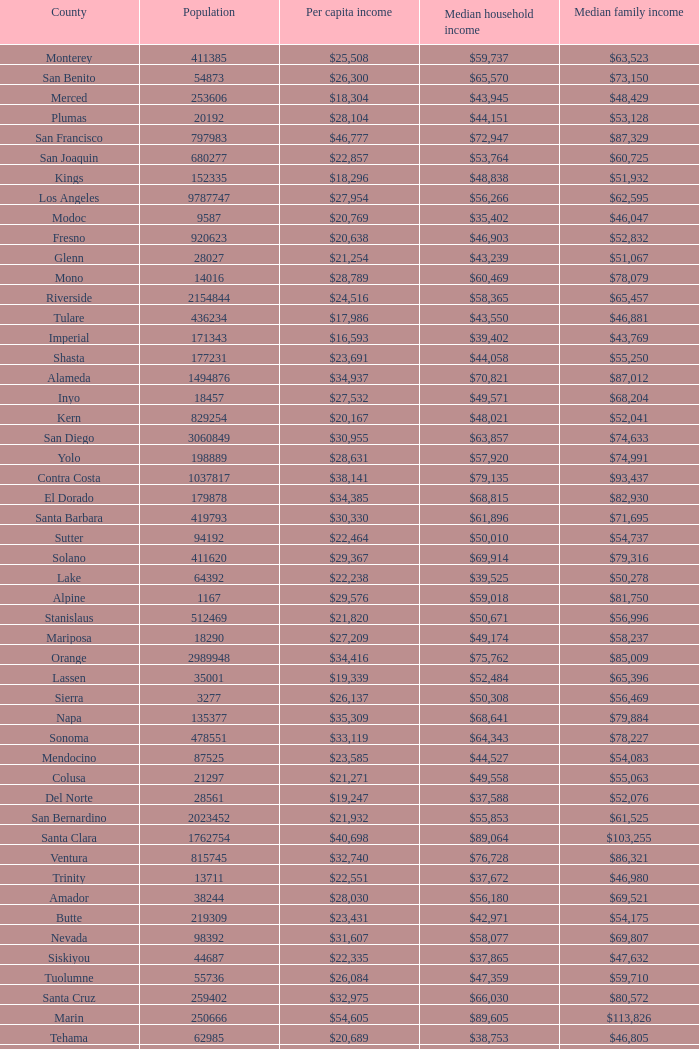What is the median household income of butte? $42,971. Can you parse all the data within this table? {'header': ['County', 'Population', 'Per capita income', 'Median household income', 'Median family income'], 'rows': [['Monterey', '411385', '$25,508', '$59,737', '$63,523'], ['San Benito', '54873', '$26,300', '$65,570', '$73,150'], ['Merced', '253606', '$18,304', '$43,945', '$48,429'], ['Plumas', '20192', '$28,104', '$44,151', '$53,128'], ['San Francisco', '797983', '$46,777', '$72,947', '$87,329'], ['San Joaquin', '680277', '$22,857', '$53,764', '$60,725'], ['Kings', '152335', '$18,296', '$48,838', '$51,932'], ['Los Angeles', '9787747', '$27,954', '$56,266', '$62,595'], ['Modoc', '9587', '$20,769', '$35,402', '$46,047'], ['Fresno', '920623', '$20,638', '$46,903', '$52,832'], ['Glenn', '28027', '$21,254', '$43,239', '$51,067'], ['Mono', '14016', '$28,789', '$60,469', '$78,079'], ['Riverside', '2154844', '$24,516', '$58,365', '$65,457'], ['Tulare', '436234', '$17,986', '$43,550', '$46,881'], ['Imperial', '171343', '$16,593', '$39,402', '$43,769'], ['Shasta', '177231', '$23,691', '$44,058', '$55,250'], ['Alameda', '1494876', '$34,937', '$70,821', '$87,012'], ['Inyo', '18457', '$27,532', '$49,571', '$68,204'], ['Kern', '829254', '$20,167', '$48,021', '$52,041'], ['San Diego', '3060849', '$30,955', '$63,857', '$74,633'], ['Yolo', '198889', '$28,631', '$57,920', '$74,991'], ['Contra Costa', '1037817', '$38,141', '$79,135', '$93,437'], ['El Dorado', '179878', '$34,385', '$68,815', '$82,930'], ['Santa Barbara', '419793', '$30,330', '$61,896', '$71,695'], ['Sutter', '94192', '$22,464', '$50,010', '$54,737'], ['Solano', '411620', '$29,367', '$69,914', '$79,316'], ['Lake', '64392', '$22,238', '$39,525', '$50,278'], ['Alpine', '1167', '$29,576', '$59,018', '$81,750'], ['Stanislaus', '512469', '$21,820', '$50,671', '$56,996'], ['Mariposa', '18290', '$27,209', '$49,174', '$58,237'], ['Orange', '2989948', '$34,416', '$75,762', '$85,009'], ['Lassen', '35001', '$19,339', '$52,484', '$65,396'], ['Sierra', '3277', '$26,137', '$50,308', '$56,469'], ['Napa', '135377', '$35,309', '$68,641', '$79,884'], ['Sonoma', '478551', '$33,119', '$64,343', '$78,227'], ['Mendocino', '87525', '$23,585', '$44,527', '$54,083'], ['Colusa', '21297', '$21,271', '$49,558', '$55,063'], ['Del Norte', '28561', '$19,247', '$37,588', '$52,076'], ['San Bernardino', '2023452', '$21,932', '$55,853', '$61,525'], ['Santa Clara', '1762754', '$40,698', '$89,064', '$103,255'], ['Ventura', '815745', '$32,740', '$76,728', '$86,321'], ['Trinity', '13711', '$22,551', '$37,672', '$46,980'], ['Amador', '38244', '$28,030', '$56,180', '$69,521'], ['Butte', '219309', '$23,431', '$42,971', '$54,175'], ['Nevada', '98392', '$31,607', '$58,077', '$69,807'], ['Siskiyou', '44687', '$22,335', '$37,865', '$47,632'], ['Tuolumne', '55736', '$26,084', '$47,359', '$59,710'], ['Santa Cruz', '259402', '$32,975', '$66,030', '$80,572'], ['Marin', '250666', '$54,605', '$89,605', '$113,826'], ['Tehama', '62985', '$20,689', '$38,753', '$46,805'], ['Madera', '149611', '$18,817', '$47,724', '$51,658'], ['Humboldt', '133585', '$24,209', '$40,376', '$52,317'], ['Placer', '343554', '$35,583', '$74,645', '$90,446'], ['San Mateo', '711622', '$45,346', '$87,633', '$104,370'], ['Sacramento', '1408480', '$27,180', '$56,553', '$65,720'], ['Calaveras', '45794', '$28,667', '$55,256', '$67,253'], ['San Luis Obispo', '267871', '$30,204', '$58,630', '$74,841']]} 